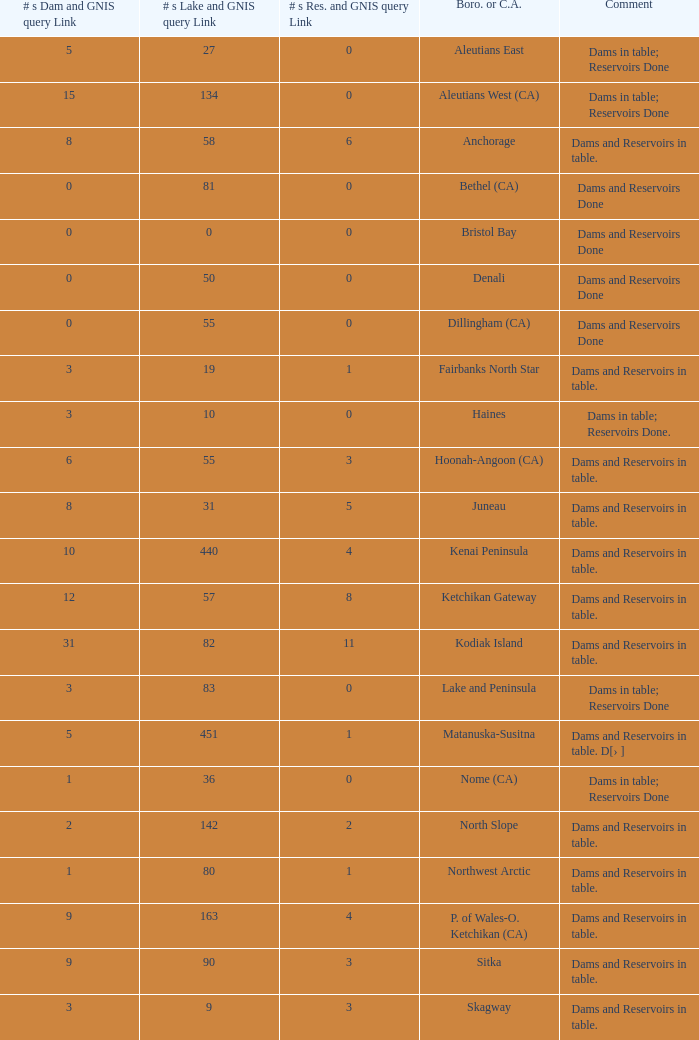Name the most numbers dam and gnis query link for borough or census area for fairbanks north star 3.0. 